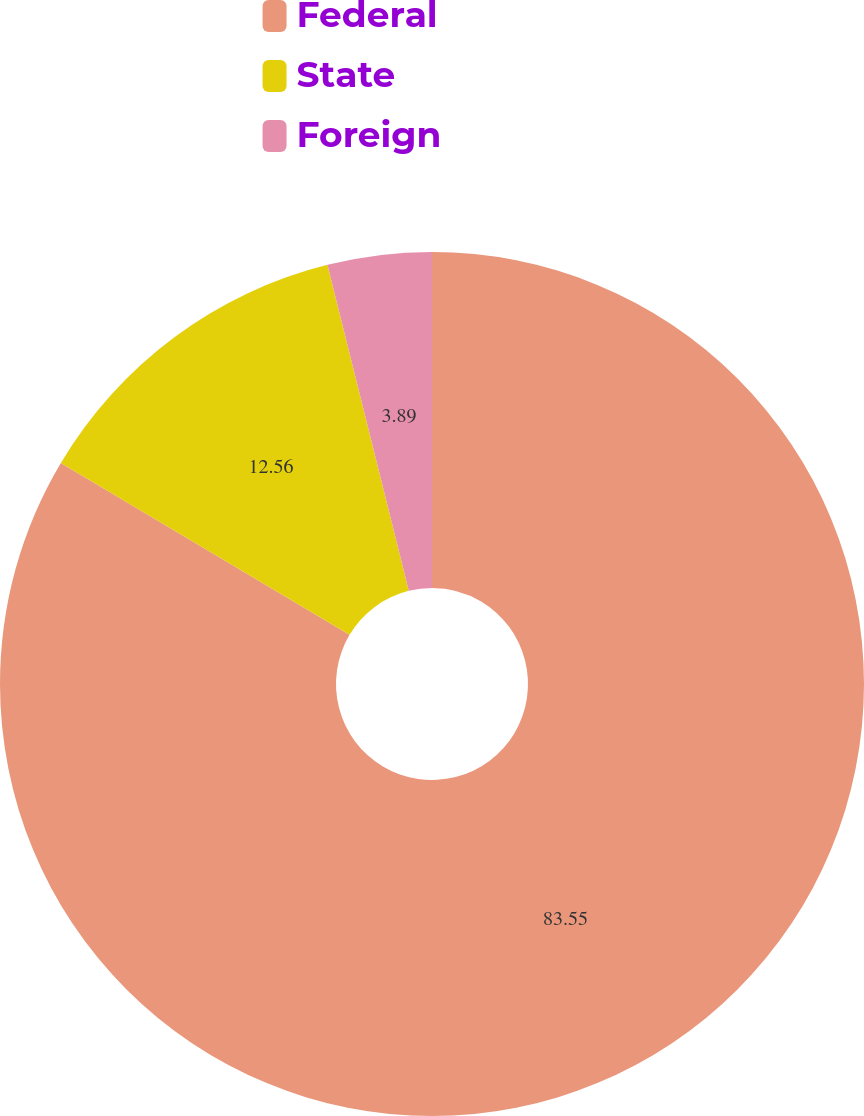Convert chart to OTSL. <chart><loc_0><loc_0><loc_500><loc_500><pie_chart><fcel>Federal<fcel>State<fcel>Foreign<nl><fcel>83.55%<fcel>12.56%<fcel>3.89%<nl></chart> 